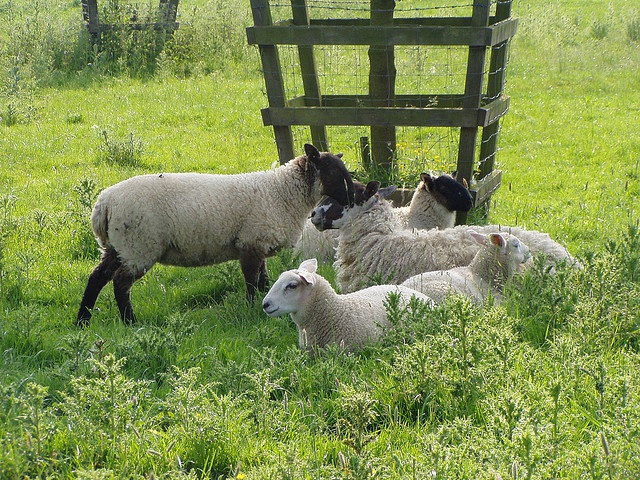Describe the objects in this image and their specific colors. I can see sheep in khaki, gray, black, and darkgray tones, sheep in khaki, gray, darkgray, and lightgray tones, sheep in khaki, gray, darkgray, lightgray, and darkgreen tones, sheep in khaki, darkgray, gray, and lightgray tones, and sheep in khaki, gray, black, and darkgray tones in this image. 